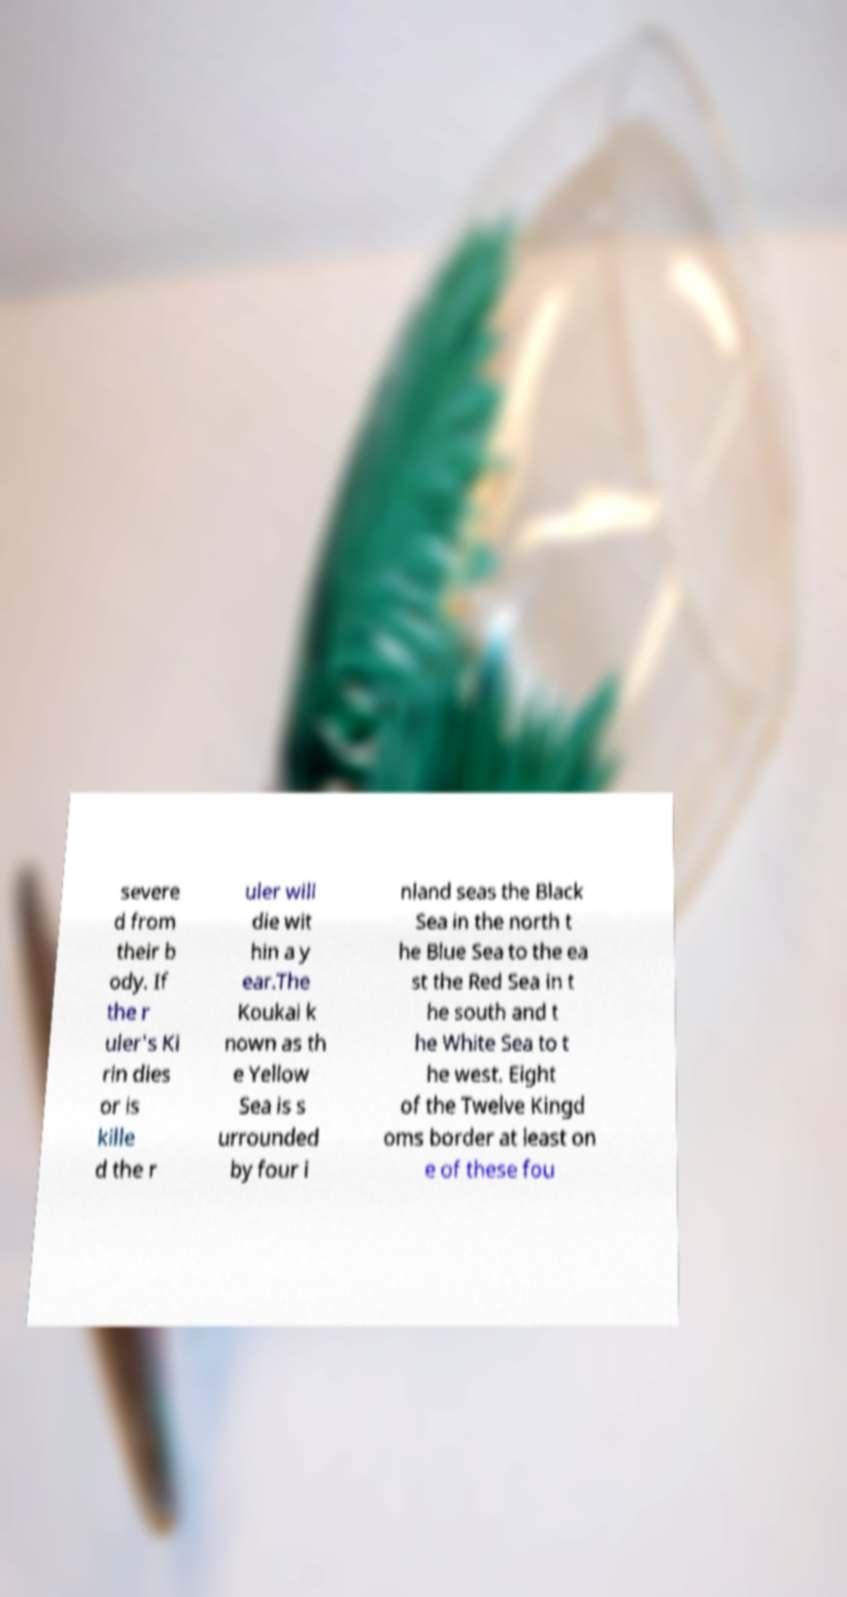Could you extract and type out the text from this image? severe d from their b ody. If the r uler's Ki rin dies or is kille d the r uler will die wit hin a y ear.The Koukai k nown as th e Yellow Sea is s urrounded by four i nland seas the Black Sea in the north t he Blue Sea to the ea st the Red Sea in t he south and t he White Sea to t he west. Eight of the Twelve Kingd oms border at least on e of these fou 